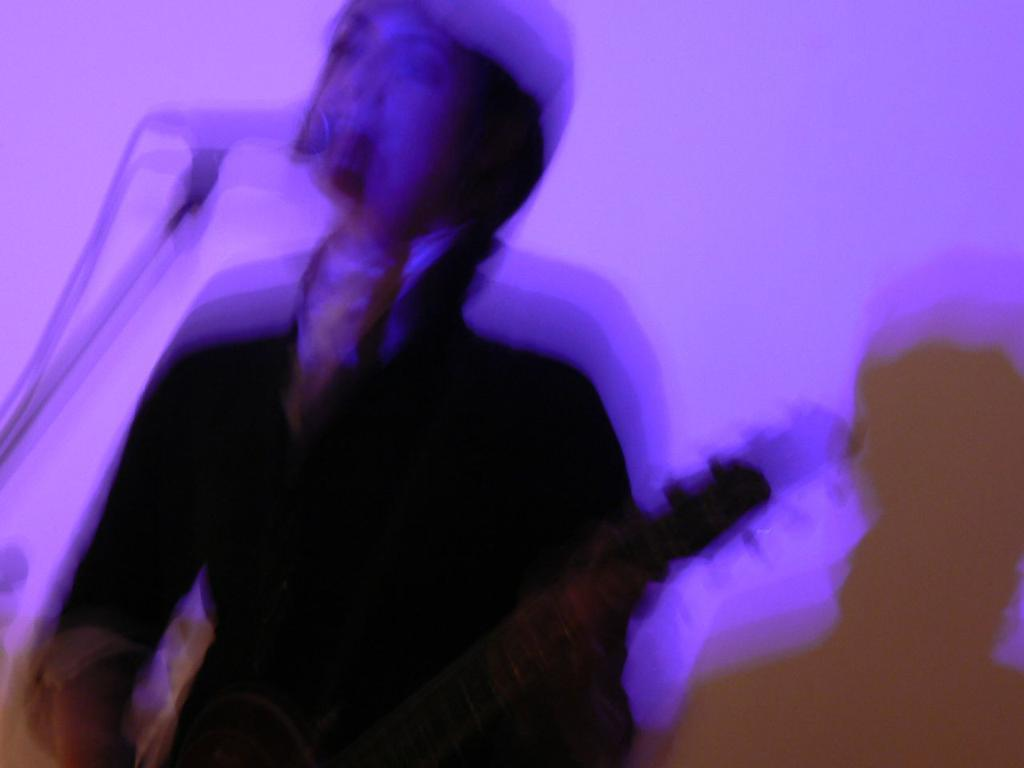What is the main subject of the image? There is a person in the image. What is the person doing in the image? The person is singing. What object is the person using while singing? The person is using a microphone. Can you see any hope floating on the lake in the image? There is no lake or hope present in the image; it features a person singing with a microphone. 